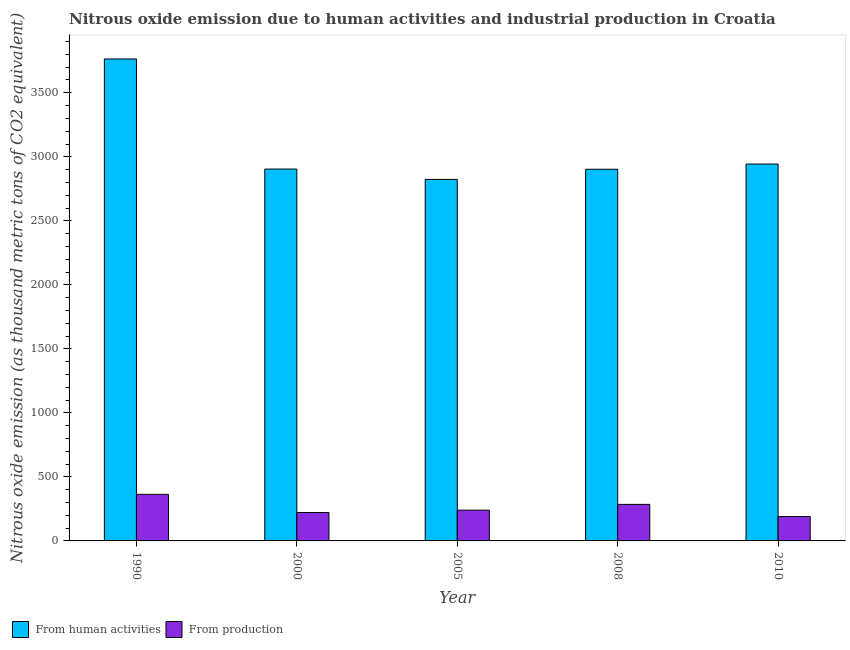Are the number of bars on each tick of the X-axis equal?
Your response must be concise. Yes. How many bars are there on the 2nd tick from the right?
Your answer should be very brief. 2. What is the amount of emissions from human activities in 2005?
Keep it short and to the point. 2823.4. Across all years, what is the maximum amount of emissions generated from industries?
Provide a short and direct response. 363.7. Across all years, what is the minimum amount of emissions generated from industries?
Give a very brief answer. 190.1. What is the total amount of emissions from human activities in the graph?
Offer a very short reply. 1.53e+04. What is the difference between the amount of emissions generated from industries in 1990 and that in 2005?
Provide a short and direct response. 123.4. What is the difference between the amount of emissions from human activities in 2005 and the amount of emissions generated from industries in 2008?
Offer a very short reply. -79.4. What is the average amount of emissions from human activities per year?
Your answer should be very brief. 3067.58. What is the ratio of the amount of emissions generated from industries in 1990 to that in 2005?
Keep it short and to the point. 1.51. Is the amount of emissions from human activities in 1990 less than that in 2005?
Give a very brief answer. No. Is the difference between the amount of emissions from human activities in 2000 and 2010 greater than the difference between the amount of emissions generated from industries in 2000 and 2010?
Your answer should be very brief. No. What is the difference between the highest and the second highest amount of emissions generated from industries?
Make the answer very short. 78.3. What is the difference between the highest and the lowest amount of emissions from human activities?
Provide a short and direct response. 940.7. Is the sum of the amount of emissions generated from industries in 1990 and 2000 greater than the maximum amount of emissions from human activities across all years?
Ensure brevity in your answer.  Yes. What does the 2nd bar from the left in 2005 represents?
Keep it short and to the point. From production. What does the 2nd bar from the right in 2005 represents?
Offer a terse response. From human activities. What is the difference between two consecutive major ticks on the Y-axis?
Your answer should be very brief. 500. Are the values on the major ticks of Y-axis written in scientific E-notation?
Your response must be concise. No. Where does the legend appear in the graph?
Provide a succinct answer. Bottom left. How many legend labels are there?
Your answer should be very brief. 2. What is the title of the graph?
Your answer should be very brief. Nitrous oxide emission due to human activities and industrial production in Croatia. Does "Working capital" appear as one of the legend labels in the graph?
Give a very brief answer. No. What is the label or title of the X-axis?
Offer a terse response. Year. What is the label or title of the Y-axis?
Your answer should be compact. Nitrous oxide emission (as thousand metric tons of CO2 equivalent). What is the Nitrous oxide emission (as thousand metric tons of CO2 equivalent) of From human activities in 1990?
Ensure brevity in your answer.  3764.1. What is the Nitrous oxide emission (as thousand metric tons of CO2 equivalent) in From production in 1990?
Your answer should be very brief. 363.7. What is the Nitrous oxide emission (as thousand metric tons of CO2 equivalent) of From human activities in 2000?
Your answer should be compact. 2904.3. What is the Nitrous oxide emission (as thousand metric tons of CO2 equivalent) of From production in 2000?
Your answer should be compact. 222. What is the Nitrous oxide emission (as thousand metric tons of CO2 equivalent) of From human activities in 2005?
Provide a succinct answer. 2823.4. What is the Nitrous oxide emission (as thousand metric tons of CO2 equivalent) in From production in 2005?
Offer a terse response. 240.3. What is the Nitrous oxide emission (as thousand metric tons of CO2 equivalent) of From human activities in 2008?
Keep it short and to the point. 2902.8. What is the Nitrous oxide emission (as thousand metric tons of CO2 equivalent) in From production in 2008?
Provide a succinct answer. 285.4. What is the Nitrous oxide emission (as thousand metric tons of CO2 equivalent) in From human activities in 2010?
Provide a succinct answer. 2943.3. What is the Nitrous oxide emission (as thousand metric tons of CO2 equivalent) of From production in 2010?
Your answer should be compact. 190.1. Across all years, what is the maximum Nitrous oxide emission (as thousand metric tons of CO2 equivalent) of From human activities?
Your answer should be compact. 3764.1. Across all years, what is the maximum Nitrous oxide emission (as thousand metric tons of CO2 equivalent) in From production?
Make the answer very short. 363.7. Across all years, what is the minimum Nitrous oxide emission (as thousand metric tons of CO2 equivalent) in From human activities?
Your response must be concise. 2823.4. Across all years, what is the minimum Nitrous oxide emission (as thousand metric tons of CO2 equivalent) of From production?
Provide a succinct answer. 190.1. What is the total Nitrous oxide emission (as thousand metric tons of CO2 equivalent) in From human activities in the graph?
Provide a short and direct response. 1.53e+04. What is the total Nitrous oxide emission (as thousand metric tons of CO2 equivalent) of From production in the graph?
Ensure brevity in your answer.  1301.5. What is the difference between the Nitrous oxide emission (as thousand metric tons of CO2 equivalent) of From human activities in 1990 and that in 2000?
Offer a terse response. 859.8. What is the difference between the Nitrous oxide emission (as thousand metric tons of CO2 equivalent) of From production in 1990 and that in 2000?
Offer a terse response. 141.7. What is the difference between the Nitrous oxide emission (as thousand metric tons of CO2 equivalent) in From human activities in 1990 and that in 2005?
Your answer should be compact. 940.7. What is the difference between the Nitrous oxide emission (as thousand metric tons of CO2 equivalent) in From production in 1990 and that in 2005?
Offer a terse response. 123.4. What is the difference between the Nitrous oxide emission (as thousand metric tons of CO2 equivalent) of From human activities in 1990 and that in 2008?
Your answer should be compact. 861.3. What is the difference between the Nitrous oxide emission (as thousand metric tons of CO2 equivalent) in From production in 1990 and that in 2008?
Offer a very short reply. 78.3. What is the difference between the Nitrous oxide emission (as thousand metric tons of CO2 equivalent) of From human activities in 1990 and that in 2010?
Provide a short and direct response. 820.8. What is the difference between the Nitrous oxide emission (as thousand metric tons of CO2 equivalent) of From production in 1990 and that in 2010?
Ensure brevity in your answer.  173.6. What is the difference between the Nitrous oxide emission (as thousand metric tons of CO2 equivalent) of From human activities in 2000 and that in 2005?
Offer a terse response. 80.9. What is the difference between the Nitrous oxide emission (as thousand metric tons of CO2 equivalent) in From production in 2000 and that in 2005?
Make the answer very short. -18.3. What is the difference between the Nitrous oxide emission (as thousand metric tons of CO2 equivalent) of From production in 2000 and that in 2008?
Provide a succinct answer. -63.4. What is the difference between the Nitrous oxide emission (as thousand metric tons of CO2 equivalent) in From human activities in 2000 and that in 2010?
Provide a succinct answer. -39. What is the difference between the Nitrous oxide emission (as thousand metric tons of CO2 equivalent) in From production in 2000 and that in 2010?
Provide a short and direct response. 31.9. What is the difference between the Nitrous oxide emission (as thousand metric tons of CO2 equivalent) in From human activities in 2005 and that in 2008?
Give a very brief answer. -79.4. What is the difference between the Nitrous oxide emission (as thousand metric tons of CO2 equivalent) in From production in 2005 and that in 2008?
Give a very brief answer. -45.1. What is the difference between the Nitrous oxide emission (as thousand metric tons of CO2 equivalent) in From human activities in 2005 and that in 2010?
Your answer should be very brief. -119.9. What is the difference between the Nitrous oxide emission (as thousand metric tons of CO2 equivalent) in From production in 2005 and that in 2010?
Give a very brief answer. 50.2. What is the difference between the Nitrous oxide emission (as thousand metric tons of CO2 equivalent) in From human activities in 2008 and that in 2010?
Your answer should be very brief. -40.5. What is the difference between the Nitrous oxide emission (as thousand metric tons of CO2 equivalent) in From production in 2008 and that in 2010?
Offer a very short reply. 95.3. What is the difference between the Nitrous oxide emission (as thousand metric tons of CO2 equivalent) of From human activities in 1990 and the Nitrous oxide emission (as thousand metric tons of CO2 equivalent) of From production in 2000?
Make the answer very short. 3542.1. What is the difference between the Nitrous oxide emission (as thousand metric tons of CO2 equivalent) of From human activities in 1990 and the Nitrous oxide emission (as thousand metric tons of CO2 equivalent) of From production in 2005?
Your answer should be very brief. 3523.8. What is the difference between the Nitrous oxide emission (as thousand metric tons of CO2 equivalent) of From human activities in 1990 and the Nitrous oxide emission (as thousand metric tons of CO2 equivalent) of From production in 2008?
Your response must be concise. 3478.7. What is the difference between the Nitrous oxide emission (as thousand metric tons of CO2 equivalent) in From human activities in 1990 and the Nitrous oxide emission (as thousand metric tons of CO2 equivalent) in From production in 2010?
Make the answer very short. 3574. What is the difference between the Nitrous oxide emission (as thousand metric tons of CO2 equivalent) of From human activities in 2000 and the Nitrous oxide emission (as thousand metric tons of CO2 equivalent) of From production in 2005?
Keep it short and to the point. 2664. What is the difference between the Nitrous oxide emission (as thousand metric tons of CO2 equivalent) in From human activities in 2000 and the Nitrous oxide emission (as thousand metric tons of CO2 equivalent) in From production in 2008?
Offer a very short reply. 2618.9. What is the difference between the Nitrous oxide emission (as thousand metric tons of CO2 equivalent) of From human activities in 2000 and the Nitrous oxide emission (as thousand metric tons of CO2 equivalent) of From production in 2010?
Make the answer very short. 2714.2. What is the difference between the Nitrous oxide emission (as thousand metric tons of CO2 equivalent) of From human activities in 2005 and the Nitrous oxide emission (as thousand metric tons of CO2 equivalent) of From production in 2008?
Offer a terse response. 2538. What is the difference between the Nitrous oxide emission (as thousand metric tons of CO2 equivalent) in From human activities in 2005 and the Nitrous oxide emission (as thousand metric tons of CO2 equivalent) in From production in 2010?
Provide a short and direct response. 2633.3. What is the difference between the Nitrous oxide emission (as thousand metric tons of CO2 equivalent) of From human activities in 2008 and the Nitrous oxide emission (as thousand metric tons of CO2 equivalent) of From production in 2010?
Give a very brief answer. 2712.7. What is the average Nitrous oxide emission (as thousand metric tons of CO2 equivalent) of From human activities per year?
Provide a succinct answer. 3067.58. What is the average Nitrous oxide emission (as thousand metric tons of CO2 equivalent) in From production per year?
Ensure brevity in your answer.  260.3. In the year 1990, what is the difference between the Nitrous oxide emission (as thousand metric tons of CO2 equivalent) in From human activities and Nitrous oxide emission (as thousand metric tons of CO2 equivalent) in From production?
Provide a succinct answer. 3400.4. In the year 2000, what is the difference between the Nitrous oxide emission (as thousand metric tons of CO2 equivalent) of From human activities and Nitrous oxide emission (as thousand metric tons of CO2 equivalent) of From production?
Offer a very short reply. 2682.3. In the year 2005, what is the difference between the Nitrous oxide emission (as thousand metric tons of CO2 equivalent) of From human activities and Nitrous oxide emission (as thousand metric tons of CO2 equivalent) of From production?
Provide a succinct answer. 2583.1. In the year 2008, what is the difference between the Nitrous oxide emission (as thousand metric tons of CO2 equivalent) in From human activities and Nitrous oxide emission (as thousand metric tons of CO2 equivalent) in From production?
Provide a succinct answer. 2617.4. In the year 2010, what is the difference between the Nitrous oxide emission (as thousand metric tons of CO2 equivalent) in From human activities and Nitrous oxide emission (as thousand metric tons of CO2 equivalent) in From production?
Provide a succinct answer. 2753.2. What is the ratio of the Nitrous oxide emission (as thousand metric tons of CO2 equivalent) in From human activities in 1990 to that in 2000?
Your response must be concise. 1.3. What is the ratio of the Nitrous oxide emission (as thousand metric tons of CO2 equivalent) in From production in 1990 to that in 2000?
Your answer should be compact. 1.64. What is the ratio of the Nitrous oxide emission (as thousand metric tons of CO2 equivalent) in From human activities in 1990 to that in 2005?
Offer a terse response. 1.33. What is the ratio of the Nitrous oxide emission (as thousand metric tons of CO2 equivalent) in From production in 1990 to that in 2005?
Provide a succinct answer. 1.51. What is the ratio of the Nitrous oxide emission (as thousand metric tons of CO2 equivalent) in From human activities in 1990 to that in 2008?
Ensure brevity in your answer.  1.3. What is the ratio of the Nitrous oxide emission (as thousand metric tons of CO2 equivalent) of From production in 1990 to that in 2008?
Your answer should be very brief. 1.27. What is the ratio of the Nitrous oxide emission (as thousand metric tons of CO2 equivalent) of From human activities in 1990 to that in 2010?
Give a very brief answer. 1.28. What is the ratio of the Nitrous oxide emission (as thousand metric tons of CO2 equivalent) of From production in 1990 to that in 2010?
Ensure brevity in your answer.  1.91. What is the ratio of the Nitrous oxide emission (as thousand metric tons of CO2 equivalent) of From human activities in 2000 to that in 2005?
Provide a succinct answer. 1.03. What is the ratio of the Nitrous oxide emission (as thousand metric tons of CO2 equivalent) in From production in 2000 to that in 2005?
Offer a very short reply. 0.92. What is the ratio of the Nitrous oxide emission (as thousand metric tons of CO2 equivalent) in From production in 2000 to that in 2008?
Provide a short and direct response. 0.78. What is the ratio of the Nitrous oxide emission (as thousand metric tons of CO2 equivalent) of From human activities in 2000 to that in 2010?
Keep it short and to the point. 0.99. What is the ratio of the Nitrous oxide emission (as thousand metric tons of CO2 equivalent) in From production in 2000 to that in 2010?
Make the answer very short. 1.17. What is the ratio of the Nitrous oxide emission (as thousand metric tons of CO2 equivalent) in From human activities in 2005 to that in 2008?
Keep it short and to the point. 0.97. What is the ratio of the Nitrous oxide emission (as thousand metric tons of CO2 equivalent) in From production in 2005 to that in 2008?
Provide a succinct answer. 0.84. What is the ratio of the Nitrous oxide emission (as thousand metric tons of CO2 equivalent) of From human activities in 2005 to that in 2010?
Provide a succinct answer. 0.96. What is the ratio of the Nitrous oxide emission (as thousand metric tons of CO2 equivalent) in From production in 2005 to that in 2010?
Your answer should be compact. 1.26. What is the ratio of the Nitrous oxide emission (as thousand metric tons of CO2 equivalent) of From human activities in 2008 to that in 2010?
Provide a succinct answer. 0.99. What is the ratio of the Nitrous oxide emission (as thousand metric tons of CO2 equivalent) in From production in 2008 to that in 2010?
Provide a short and direct response. 1.5. What is the difference between the highest and the second highest Nitrous oxide emission (as thousand metric tons of CO2 equivalent) of From human activities?
Offer a very short reply. 820.8. What is the difference between the highest and the second highest Nitrous oxide emission (as thousand metric tons of CO2 equivalent) in From production?
Your answer should be compact. 78.3. What is the difference between the highest and the lowest Nitrous oxide emission (as thousand metric tons of CO2 equivalent) of From human activities?
Your answer should be very brief. 940.7. What is the difference between the highest and the lowest Nitrous oxide emission (as thousand metric tons of CO2 equivalent) in From production?
Your answer should be compact. 173.6. 